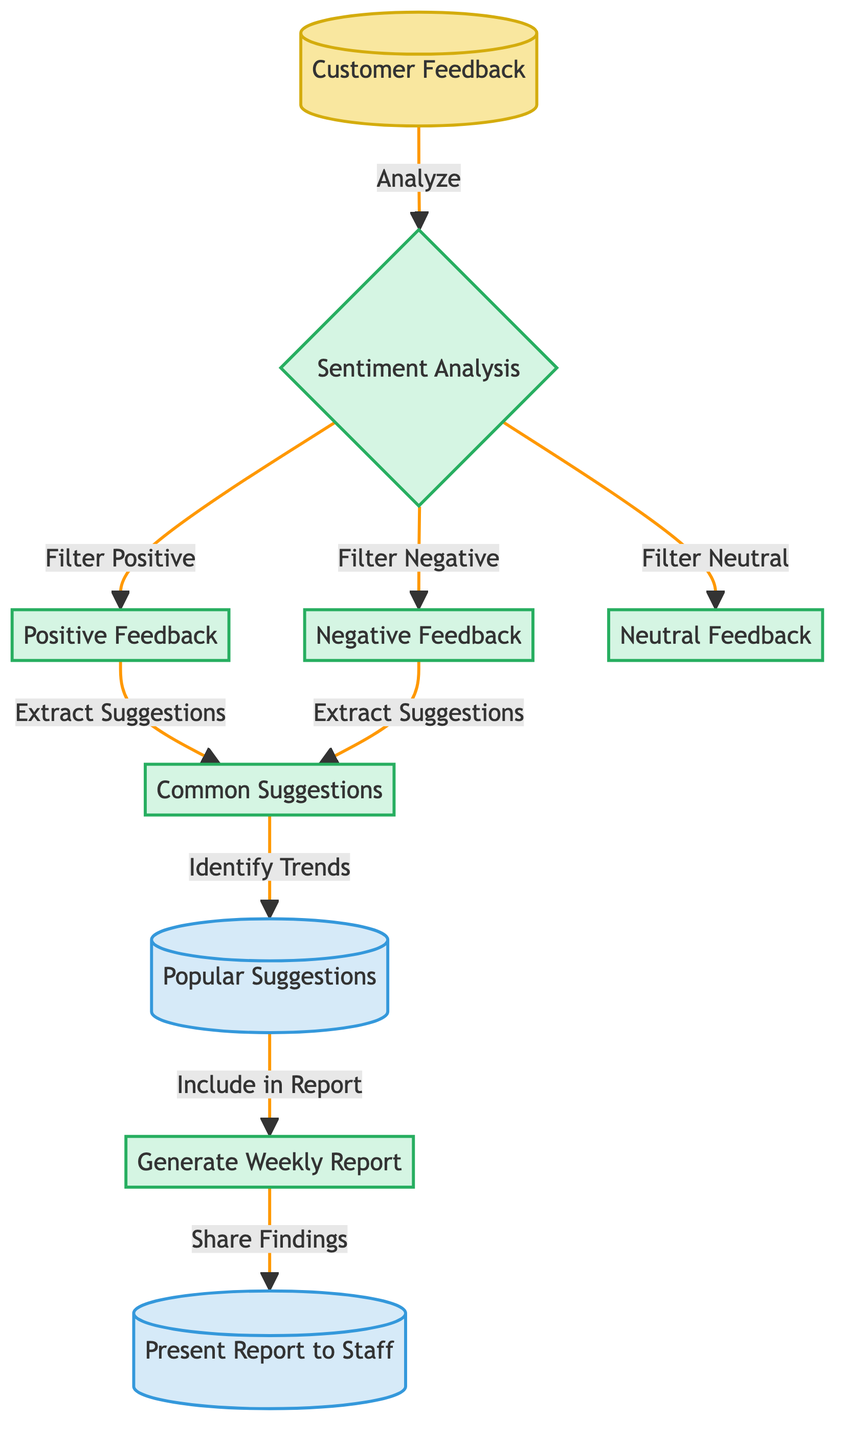What are the three types of feedback in the diagram? The diagram lists three types of feedback: Positive Feedback, Negative Feedback, and Neutral Feedback. These are directly represented as nodes that categorize the customer feedback after the sentiment analysis step.
Answer: Positive Feedback, Negative Feedback, Neutral Feedback How many nodes are in the process section? In the diagram, there are five process nodes: Sentiment Analysis, Positive Feedback, Negative Feedback, Neutral Feedback, and Common Suggestions, which are all indicated under the process classification.
Answer: five What action is taken after extracting suggestions? After extracting suggestions from both Positive and Negative feedback, the next action is identifying trends, as indicated by the path flowing from the Common Suggestions node to the Popular Suggestions node.
Answer: Identify Trends What is the output after the "Generate Weekly Report" process? The next output after "Generate Weekly Report" is "Present Report to Staff," showing that it is the final action in the flow. This indicates that the findings from the report will be shared with the staff as a result.
Answer: Present Report to Staff Which feedback type leads directly to extracting suggestions? Both Positive Feedback and Negative Feedback lead directly to the "Extract Suggestions" step, since they both branch from the Sentiment Analysis node as part of the process flow.
Answer: Positive Feedback, Negative Feedback 